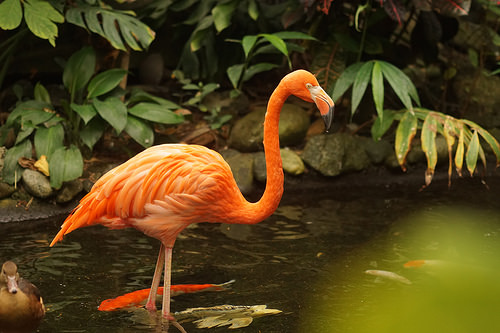<image>
Is there a bird next to the fish? Yes. The bird is positioned adjacent to the fish, located nearby in the same general area. Is there a flamingo above the duck? Yes. The flamingo is positioned above the duck in the vertical space, higher up in the scene. Is there a flamingo above the fish? No. The flamingo is not positioned above the fish. The vertical arrangement shows a different relationship. 